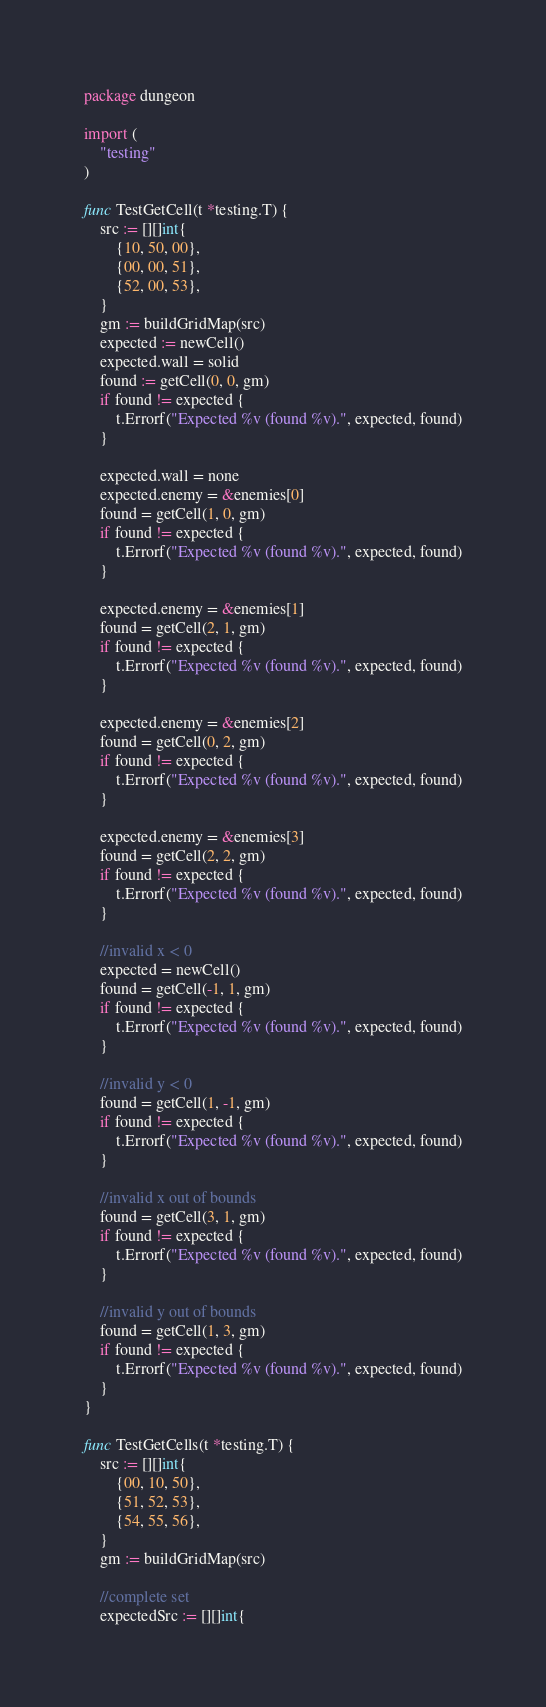Convert code to text. <code><loc_0><loc_0><loc_500><loc_500><_Go_>package dungeon

import (
	"testing"
)

func TestGetCell(t *testing.T) {
	src := [][]int{
		{10, 50, 00},
		{00, 00, 51},
		{52, 00, 53},
	}
	gm := buildGridMap(src)
	expected := newCell()
	expected.wall = solid
	found := getCell(0, 0, gm)
	if found != expected {
		t.Errorf("Expected %v (found %v).", expected, found)
	}

	expected.wall = none
	expected.enemy = &enemies[0]
	found = getCell(1, 0, gm)
	if found != expected {
		t.Errorf("Expected %v (found %v).", expected, found)
	}

	expected.enemy = &enemies[1]
	found = getCell(2, 1, gm)
	if found != expected {
		t.Errorf("Expected %v (found %v).", expected, found)
	}

	expected.enemy = &enemies[2]
	found = getCell(0, 2, gm)
	if found != expected {
		t.Errorf("Expected %v (found %v).", expected, found)
	}

	expected.enemy = &enemies[3]
	found = getCell(2, 2, gm)
	if found != expected {
		t.Errorf("Expected %v (found %v).", expected, found)
	}

	//invalid x < 0
	expected = newCell()
	found = getCell(-1, 1, gm)
	if found != expected {
		t.Errorf("Expected %v (found %v).", expected, found)
	}

	//invalid y < 0
	found = getCell(1, -1, gm)
	if found != expected {
		t.Errorf("Expected %v (found %v).", expected, found)
	}

	//invalid x out of bounds
	found = getCell(3, 1, gm)
	if found != expected {
		t.Errorf("Expected %v (found %v).", expected, found)
	}

	//invalid y out of bounds
	found = getCell(1, 3, gm)
	if found != expected {
		t.Errorf("Expected %v (found %v).", expected, found)
	}
}

func TestGetCells(t *testing.T) {
	src := [][]int{
		{00, 10, 50},
		{51, 52, 53},
		{54, 55, 56},
	}
	gm := buildGridMap(src)

	//complete set
	expectedSrc := [][]int{</code> 